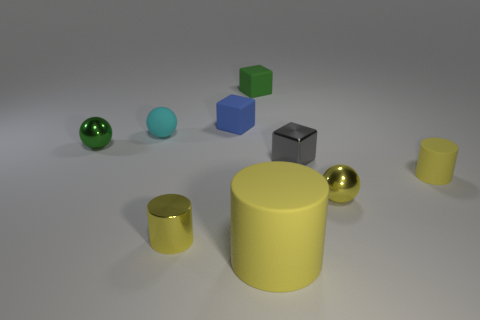Is there a red cylinder that has the same size as the cyan thing?
Keep it short and to the point. No. What is the material of the green ball that is the same size as the gray metal cube?
Offer a terse response. Metal. Does the green matte cube have the same size as the yellow rubber thing that is left of the yellow sphere?
Offer a very short reply. No. What is the green object on the right side of the tiny cyan rubber ball made of?
Your response must be concise. Rubber. Are there an equal number of small things to the right of the tiny yellow shiny sphere and tiny yellow cylinders?
Your response must be concise. No. Do the blue rubber cube and the metal cube have the same size?
Keep it short and to the point. Yes. There is a small metallic sphere that is behind the cylinder that is on the right side of the gray cube; is there a small object that is in front of it?
Keep it short and to the point. Yes. There is a green object that is the same shape as the tiny gray object; what is it made of?
Your answer should be compact. Rubber. There is a small ball in front of the small yellow rubber object; how many small shiny objects are behind it?
Ensure brevity in your answer.  2. What size is the yellow rubber cylinder that is behind the metal ball to the right of the tiny yellow cylinder that is to the left of the gray metallic thing?
Offer a terse response. Small. 